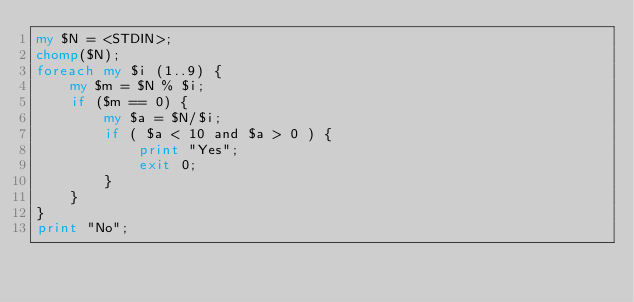<code> <loc_0><loc_0><loc_500><loc_500><_Perl_>my $N = <STDIN>;
chomp($N);
foreach my $i (1..9) {
    my $m = $N % $i;
    if ($m == 0) {
        my $a = $N/$i;
        if ( $a < 10 and $a > 0 ) {
            print "Yes";
            exit 0;
        }
    }
}
print "No";</code> 